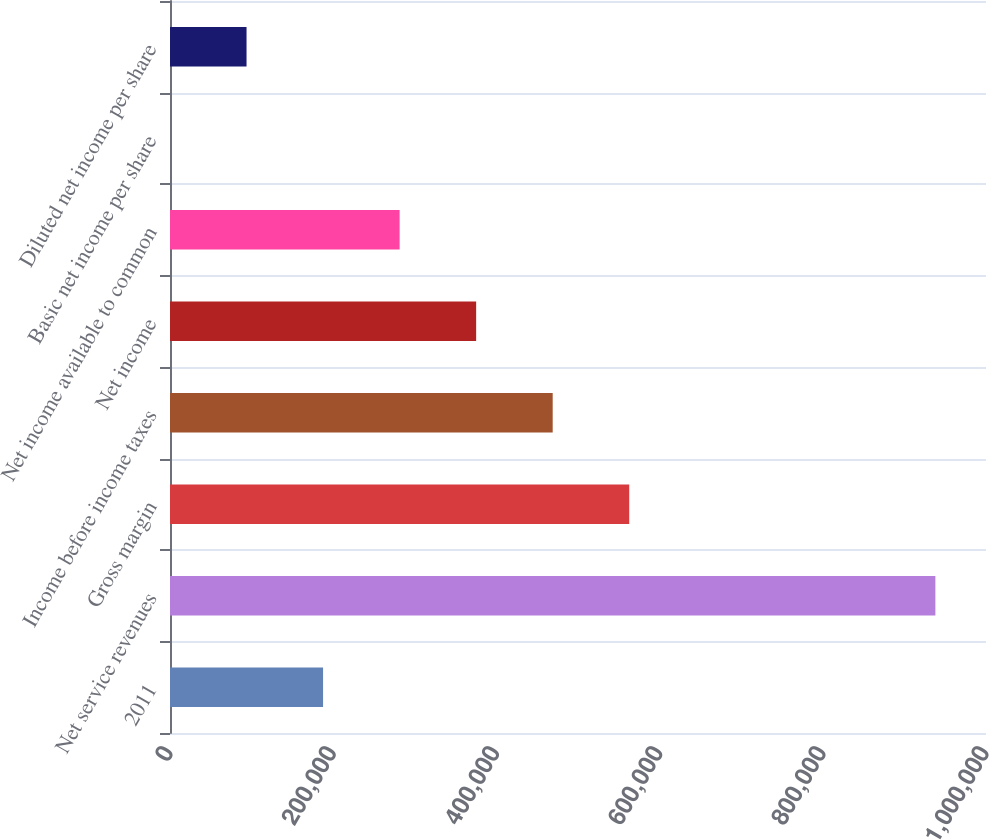<chart> <loc_0><loc_0><loc_500><loc_500><bar_chart><fcel>2011<fcel>Net service revenues<fcel>Gross margin<fcel>Income before income taxes<fcel>Net income<fcel>Net income available to common<fcel>Basic net income per share<fcel>Diluted net income per share<nl><fcel>187593<fcel>937966<fcel>562780<fcel>468983<fcel>375187<fcel>281390<fcel>0.25<fcel>93796.8<nl></chart> 